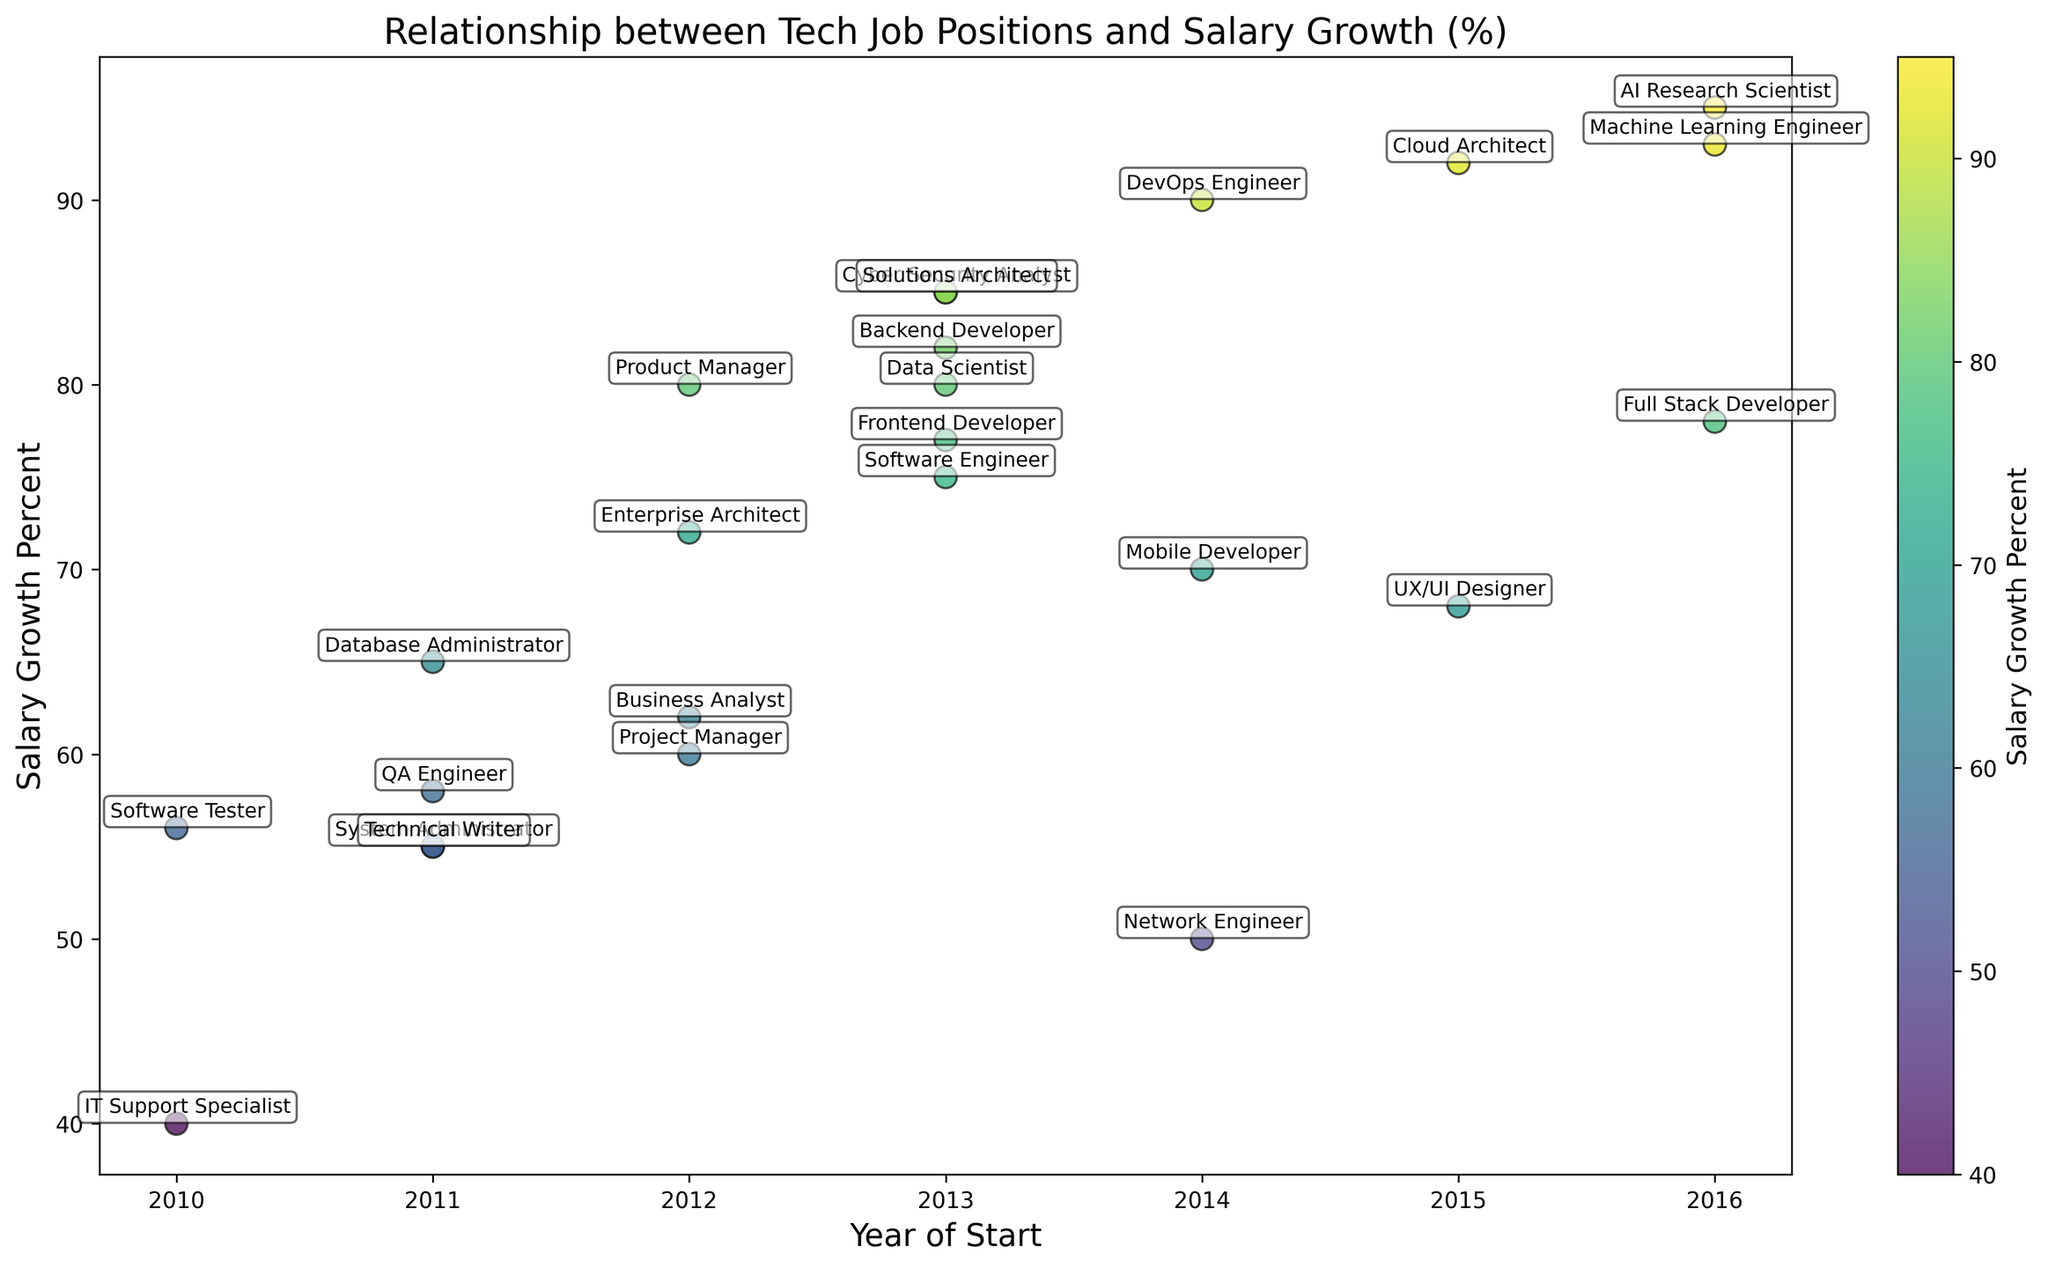what does the scatter plot show? The scatter plot displays the relationship between tech job positions and their salary growth percentages over the last decade. Each point represents a specific job position with its corresponding year of start and salary growth percent. Colors indicate different levels of salary growth, and text annotations describe job positions.
Answer: Relationship between tech positions and salary growth Which job position has the highest salary growth percent? By looking at the scatter plot, the job position with the highest salary growth percent has the highest vertical position in terms of salary growth percent. This position is annotated as "AI Research Scientist" with a salary growth percent of 95%.
Answer: AI Research Scientist Which year has the highest average salary growth percent for tech positions? To find this, visually estimate the average vertical positions of the points for each year on the horizontal axis. The year with the highest concentration of points at the higher end of the salary growth percent axis indicates higher average growth. By observing the scatter plot, the year 2016 seems to have higher average salary growths.
Answer: 2016 How does the salary growth percent of a Data Scientist compare to that of a Business Analyst? Look for the points labeled "Data Scientist" and "Business Analyst," and compare their vertical positions on the salary growth percent axis. Data Scientist has a higher vertical position (80%) compared to Business Analyst (62%).
Answer: Data Scientist has higher salary growth Which job positions have salary growth percentages greater than or equal to Backend Developer? Identify the salary growth percent for Backend Developer which is 82% and look for other job positions with equal or greater vertical positions. The job positions meeting this criterion are Cyber Security Analyst (85%), DevOps Engineer (90%), Cloud Architect (92%), AI Research Scientist (95%), Machine Learning Engineer (93%), and Solutions Architect (85%).
Answer: Cyber Security Analyst, DevOps Engineer, Cloud Architect, AI Research Scientist, Machine Learning Engineer, Solutions Architect What is the color pattern representing salary growth? The color of the markers represents the salary growth percent. The scatter plot uses a colormap called 'viridis' which varies from purple (lower salary growth) to yellow (higher salary growth).
Answer: Purple to yellow How many job positions started in 2014 and what are their salary growth percentages? Locate the year 2014 on the horizontal axis and count the number of points at that position. The annotated positions are Network Engineer, DevOps Engineer, and Mobile Developer with salary growth percentages of 50%, 90%, and 70% respectively.
Answer: Three positions: Network Engineer (50%), DevOps Engineer (90%), Mobile Developer (70%) Are there any job positions that have a salary growth percent below 50%? Look for points with vertical positions below the 50% mark on the salary growth percent axis. The only annotated position below this threshold is IT Support Specialist with a salary growth percent of 40%.
Answer: IT Support Specialist Which job position with a starting year of 2011 has the highest salary growth percent? Locate the year 2011 on the horizontal axis and identify the points for that year. Compare their vertical positions (salary growth percent). Technical Writer and System Administrator both have salary growth percentages of 55%, so both are tied for the highest in 2011.
Answer: Technical Writer, System Administrator 